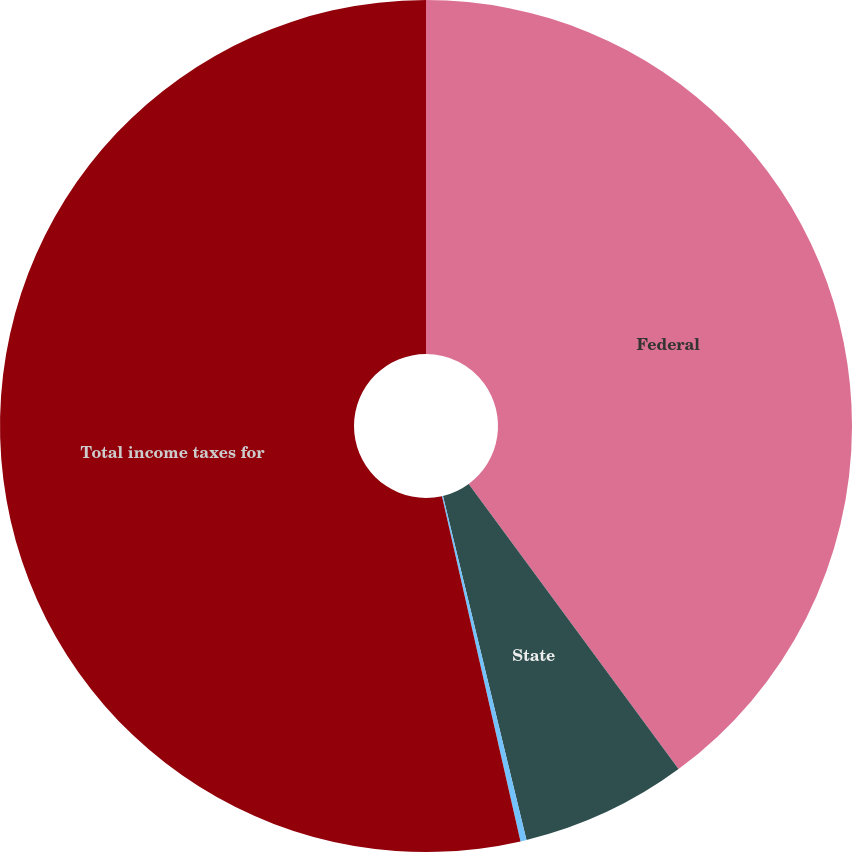<chart> <loc_0><loc_0><loc_500><loc_500><pie_chart><fcel>Federal<fcel>State<fcel>Foreign<fcel>Total income taxes for<nl><fcel>39.9%<fcel>6.31%<fcel>0.23%<fcel>53.56%<nl></chart> 